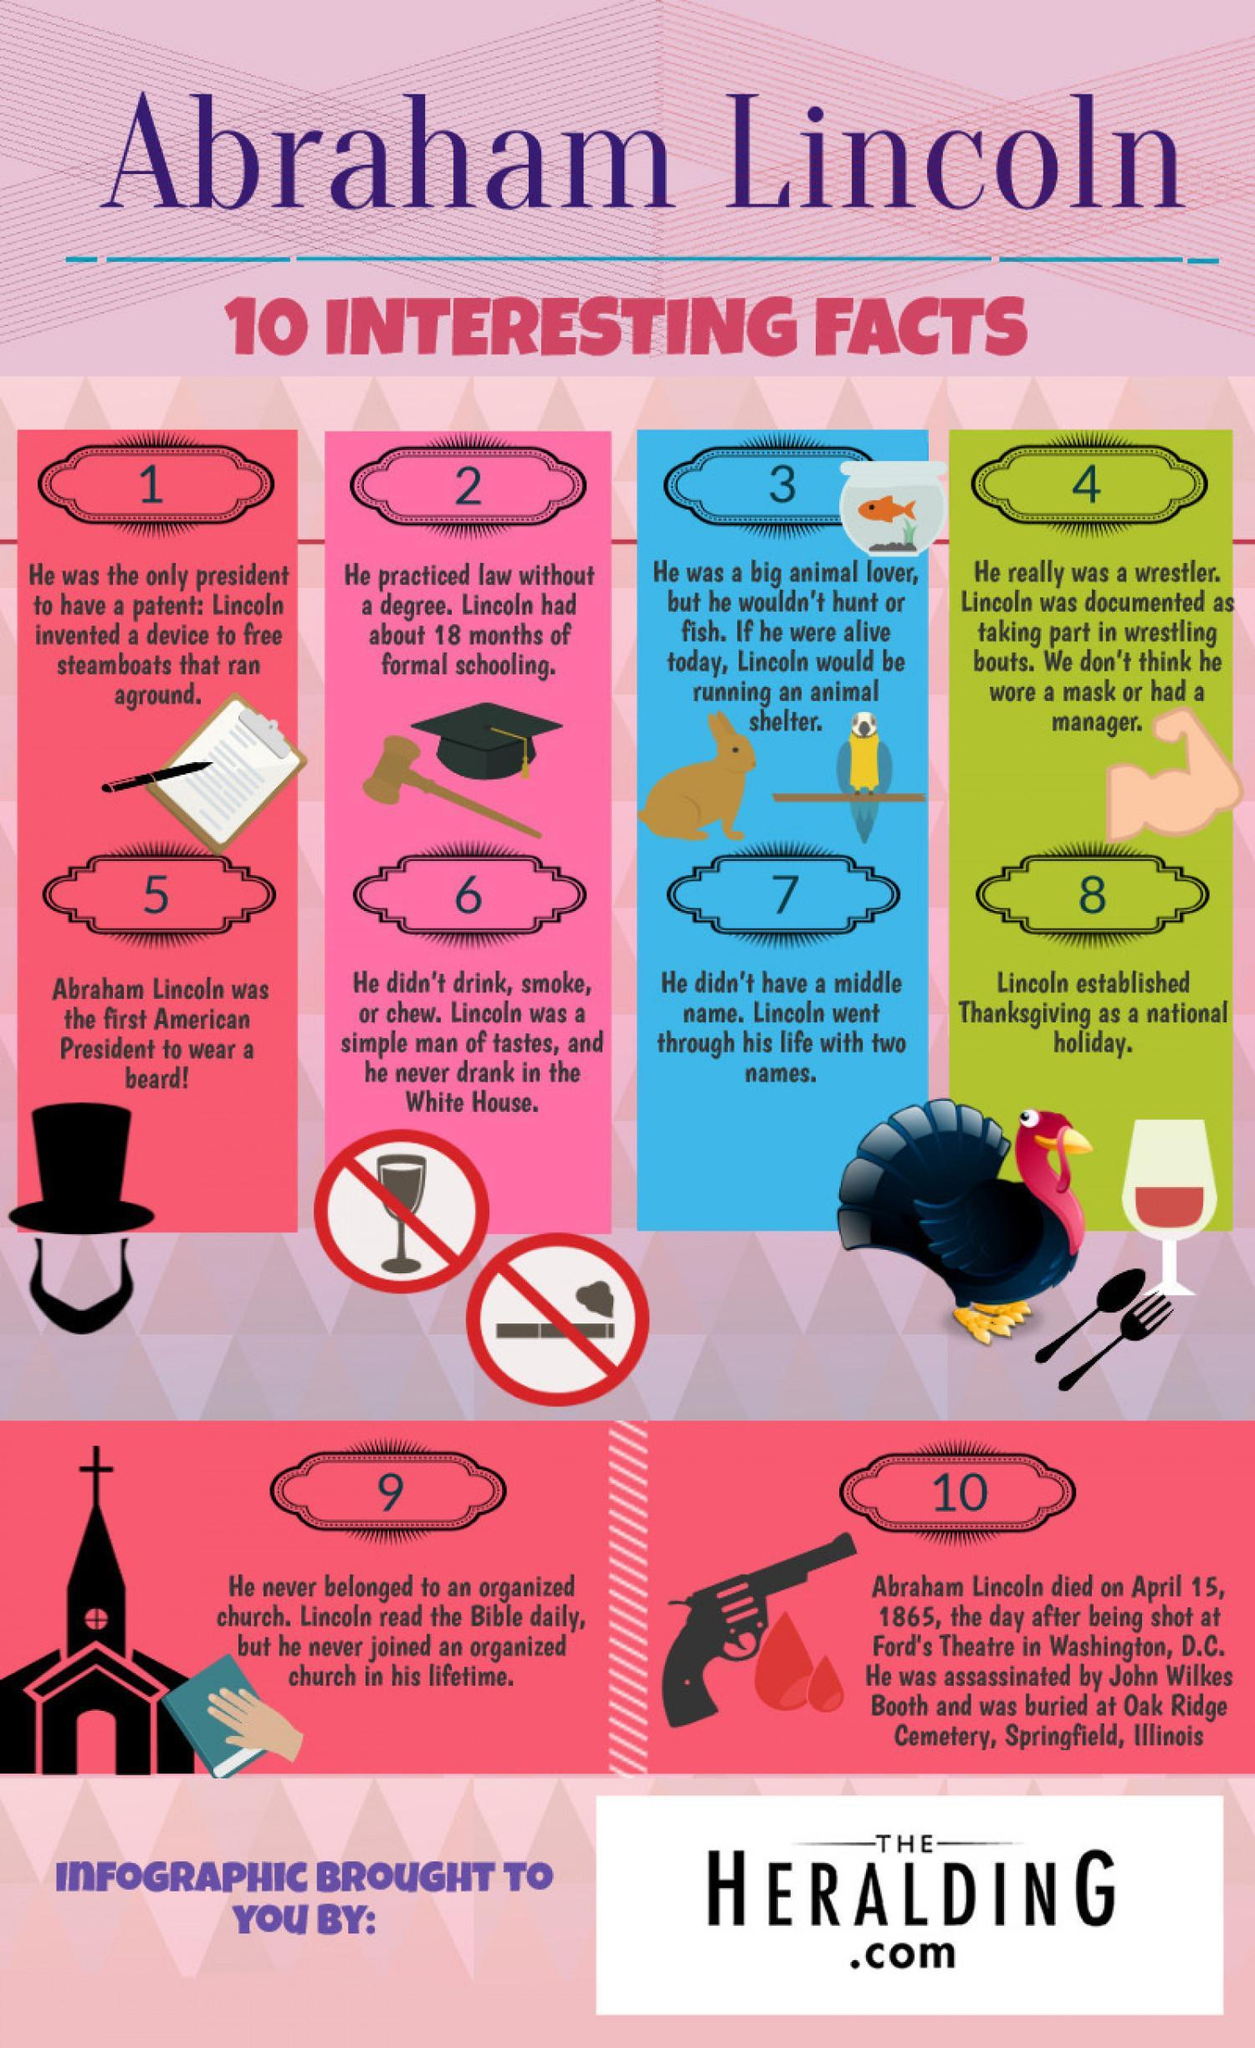why did Abraham Lincoln owned a patent?
Answer the question with a short phrase. he invented a device to free steamboats that ran aground name the animal shown in the third interesting fact column,rabbit or rat? rabbit name the place where abraham lincoln was shot dead? ford's theatre in washington, D.C 